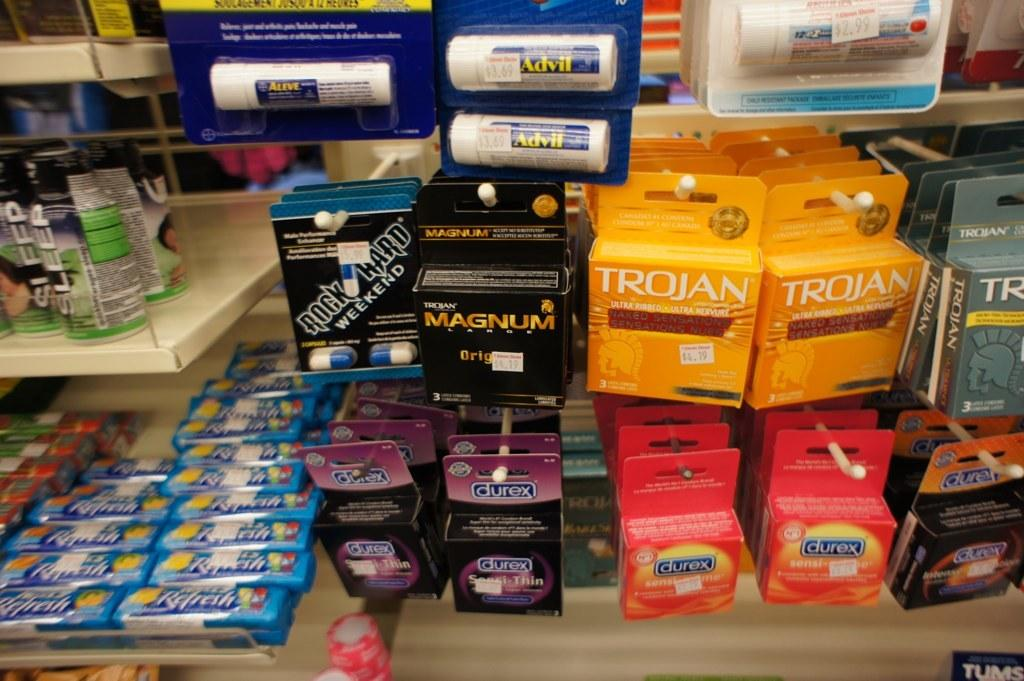<image>
Relay a brief, clear account of the picture shown. Several condom packages are on hooks at the store, including Trojan and Magnum brands. 